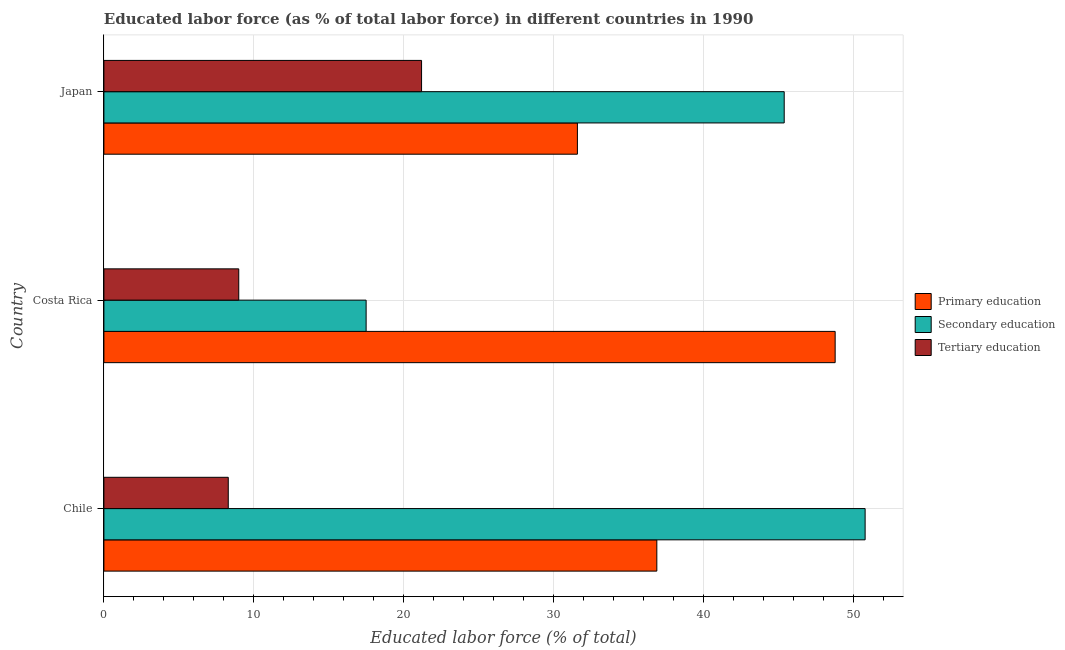Are the number of bars per tick equal to the number of legend labels?
Give a very brief answer. Yes. Are the number of bars on each tick of the Y-axis equal?
Provide a short and direct response. Yes. How many bars are there on the 1st tick from the top?
Your response must be concise. 3. What is the percentage of labor force who received primary education in Japan?
Provide a short and direct response. 31.6. Across all countries, what is the maximum percentage of labor force who received primary education?
Provide a short and direct response. 48.8. Across all countries, what is the minimum percentage of labor force who received primary education?
Your answer should be very brief. 31.6. In which country was the percentage of labor force who received secondary education minimum?
Offer a very short reply. Costa Rica. What is the total percentage of labor force who received secondary education in the graph?
Give a very brief answer. 113.7. What is the difference between the percentage of labor force who received primary education in Costa Rica and the percentage of labor force who received secondary education in Japan?
Make the answer very short. 3.4. What is the average percentage of labor force who received secondary education per country?
Provide a short and direct response. 37.9. What is the difference between the percentage of labor force who received secondary education and percentage of labor force who received primary education in Costa Rica?
Ensure brevity in your answer.  -31.3. What is the ratio of the percentage of labor force who received tertiary education in Chile to that in Costa Rica?
Offer a terse response. 0.92. Is the percentage of labor force who received secondary education in Costa Rica less than that in Japan?
Make the answer very short. Yes. What is the difference between the highest and the second highest percentage of labor force who received secondary education?
Offer a terse response. 5.4. What is the difference between the highest and the lowest percentage of labor force who received primary education?
Offer a terse response. 17.2. In how many countries, is the percentage of labor force who received tertiary education greater than the average percentage of labor force who received tertiary education taken over all countries?
Your answer should be compact. 1. What does the 3rd bar from the top in Costa Rica represents?
Make the answer very short. Primary education. How many bars are there?
Your answer should be compact. 9. How many countries are there in the graph?
Provide a succinct answer. 3. What is the difference between two consecutive major ticks on the X-axis?
Provide a short and direct response. 10. Does the graph contain any zero values?
Offer a very short reply. No. What is the title of the graph?
Make the answer very short. Educated labor force (as % of total labor force) in different countries in 1990. What is the label or title of the X-axis?
Your answer should be very brief. Educated labor force (% of total). What is the label or title of the Y-axis?
Offer a terse response. Country. What is the Educated labor force (% of total) in Primary education in Chile?
Keep it short and to the point. 36.9. What is the Educated labor force (% of total) of Secondary education in Chile?
Your answer should be compact. 50.8. What is the Educated labor force (% of total) of Tertiary education in Chile?
Ensure brevity in your answer.  8.3. What is the Educated labor force (% of total) in Primary education in Costa Rica?
Your answer should be compact. 48.8. What is the Educated labor force (% of total) of Secondary education in Costa Rica?
Provide a succinct answer. 17.5. What is the Educated labor force (% of total) of Primary education in Japan?
Ensure brevity in your answer.  31.6. What is the Educated labor force (% of total) of Secondary education in Japan?
Your response must be concise. 45.4. What is the Educated labor force (% of total) of Tertiary education in Japan?
Provide a short and direct response. 21.2. Across all countries, what is the maximum Educated labor force (% of total) of Primary education?
Provide a succinct answer. 48.8. Across all countries, what is the maximum Educated labor force (% of total) of Secondary education?
Your answer should be compact. 50.8. Across all countries, what is the maximum Educated labor force (% of total) in Tertiary education?
Offer a very short reply. 21.2. Across all countries, what is the minimum Educated labor force (% of total) of Primary education?
Provide a short and direct response. 31.6. Across all countries, what is the minimum Educated labor force (% of total) of Tertiary education?
Provide a succinct answer. 8.3. What is the total Educated labor force (% of total) in Primary education in the graph?
Offer a terse response. 117.3. What is the total Educated labor force (% of total) in Secondary education in the graph?
Make the answer very short. 113.7. What is the total Educated labor force (% of total) of Tertiary education in the graph?
Your answer should be very brief. 38.5. What is the difference between the Educated labor force (% of total) of Secondary education in Chile and that in Costa Rica?
Keep it short and to the point. 33.3. What is the difference between the Educated labor force (% of total) of Primary education in Chile and that in Japan?
Provide a short and direct response. 5.3. What is the difference between the Educated labor force (% of total) in Tertiary education in Chile and that in Japan?
Your answer should be very brief. -12.9. What is the difference between the Educated labor force (% of total) in Secondary education in Costa Rica and that in Japan?
Your response must be concise. -27.9. What is the difference between the Educated labor force (% of total) of Tertiary education in Costa Rica and that in Japan?
Keep it short and to the point. -12.2. What is the difference between the Educated labor force (% of total) of Primary education in Chile and the Educated labor force (% of total) of Secondary education in Costa Rica?
Provide a short and direct response. 19.4. What is the difference between the Educated labor force (% of total) of Primary education in Chile and the Educated labor force (% of total) of Tertiary education in Costa Rica?
Your answer should be compact. 27.9. What is the difference between the Educated labor force (% of total) in Secondary education in Chile and the Educated labor force (% of total) in Tertiary education in Costa Rica?
Make the answer very short. 41.8. What is the difference between the Educated labor force (% of total) in Secondary education in Chile and the Educated labor force (% of total) in Tertiary education in Japan?
Provide a succinct answer. 29.6. What is the difference between the Educated labor force (% of total) of Primary education in Costa Rica and the Educated labor force (% of total) of Secondary education in Japan?
Provide a short and direct response. 3.4. What is the difference between the Educated labor force (% of total) in Primary education in Costa Rica and the Educated labor force (% of total) in Tertiary education in Japan?
Offer a very short reply. 27.6. What is the average Educated labor force (% of total) of Primary education per country?
Ensure brevity in your answer.  39.1. What is the average Educated labor force (% of total) in Secondary education per country?
Offer a terse response. 37.9. What is the average Educated labor force (% of total) of Tertiary education per country?
Ensure brevity in your answer.  12.83. What is the difference between the Educated labor force (% of total) of Primary education and Educated labor force (% of total) of Secondary education in Chile?
Your answer should be compact. -13.9. What is the difference between the Educated labor force (% of total) in Primary education and Educated labor force (% of total) in Tertiary education in Chile?
Ensure brevity in your answer.  28.6. What is the difference between the Educated labor force (% of total) in Secondary education and Educated labor force (% of total) in Tertiary education in Chile?
Your answer should be very brief. 42.5. What is the difference between the Educated labor force (% of total) of Primary education and Educated labor force (% of total) of Secondary education in Costa Rica?
Make the answer very short. 31.3. What is the difference between the Educated labor force (% of total) of Primary education and Educated labor force (% of total) of Tertiary education in Costa Rica?
Offer a terse response. 39.8. What is the difference between the Educated labor force (% of total) of Secondary education and Educated labor force (% of total) of Tertiary education in Japan?
Provide a succinct answer. 24.2. What is the ratio of the Educated labor force (% of total) in Primary education in Chile to that in Costa Rica?
Make the answer very short. 0.76. What is the ratio of the Educated labor force (% of total) of Secondary education in Chile to that in Costa Rica?
Your answer should be compact. 2.9. What is the ratio of the Educated labor force (% of total) in Tertiary education in Chile to that in Costa Rica?
Ensure brevity in your answer.  0.92. What is the ratio of the Educated labor force (% of total) in Primary education in Chile to that in Japan?
Provide a short and direct response. 1.17. What is the ratio of the Educated labor force (% of total) in Secondary education in Chile to that in Japan?
Your answer should be compact. 1.12. What is the ratio of the Educated labor force (% of total) in Tertiary education in Chile to that in Japan?
Offer a very short reply. 0.39. What is the ratio of the Educated labor force (% of total) of Primary education in Costa Rica to that in Japan?
Your answer should be very brief. 1.54. What is the ratio of the Educated labor force (% of total) of Secondary education in Costa Rica to that in Japan?
Your answer should be very brief. 0.39. What is the ratio of the Educated labor force (% of total) of Tertiary education in Costa Rica to that in Japan?
Your response must be concise. 0.42. What is the difference between the highest and the lowest Educated labor force (% of total) of Primary education?
Offer a terse response. 17.2. What is the difference between the highest and the lowest Educated labor force (% of total) of Secondary education?
Your answer should be very brief. 33.3. What is the difference between the highest and the lowest Educated labor force (% of total) in Tertiary education?
Your response must be concise. 12.9. 